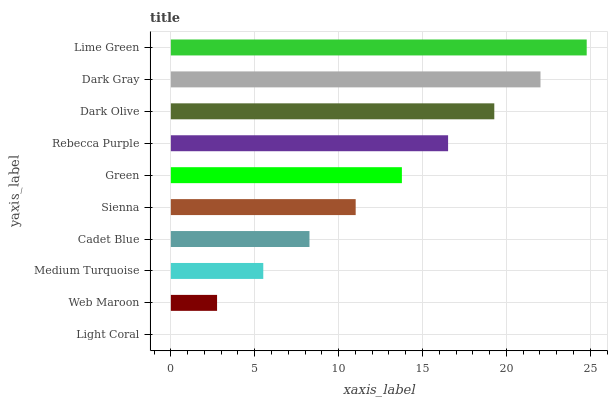Is Light Coral the minimum?
Answer yes or no. Yes. Is Lime Green the maximum?
Answer yes or no. Yes. Is Web Maroon the minimum?
Answer yes or no. No. Is Web Maroon the maximum?
Answer yes or no. No. Is Web Maroon greater than Light Coral?
Answer yes or no. Yes. Is Light Coral less than Web Maroon?
Answer yes or no. Yes. Is Light Coral greater than Web Maroon?
Answer yes or no. No. Is Web Maroon less than Light Coral?
Answer yes or no. No. Is Green the high median?
Answer yes or no. Yes. Is Sienna the low median?
Answer yes or no. Yes. Is Dark Olive the high median?
Answer yes or no. No. Is Medium Turquoise the low median?
Answer yes or no. No. 